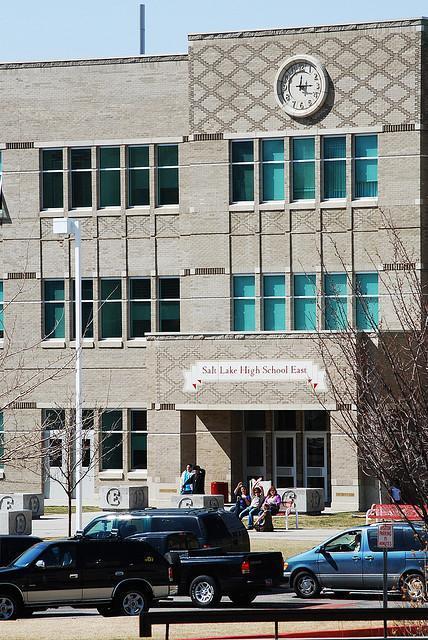What age people mostly utilize this space?
From the following four choices, select the correct answer to address the question.
Options: Toddlers, teens, senior citizens, adults. Teens. 